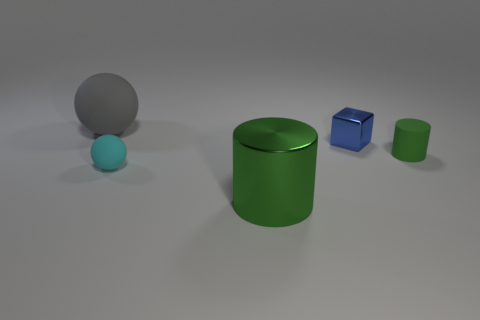Add 4 tiny purple blocks. How many objects exist? 9 Subtract all balls. How many objects are left? 3 Add 1 tiny shiny spheres. How many tiny shiny spheres exist? 1 Subtract 1 blue cubes. How many objects are left? 4 Subtract all tiny green matte cylinders. Subtract all cyan matte things. How many objects are left? 3 Add 5 tiny metal things. How many tiny metal things are left? 6 